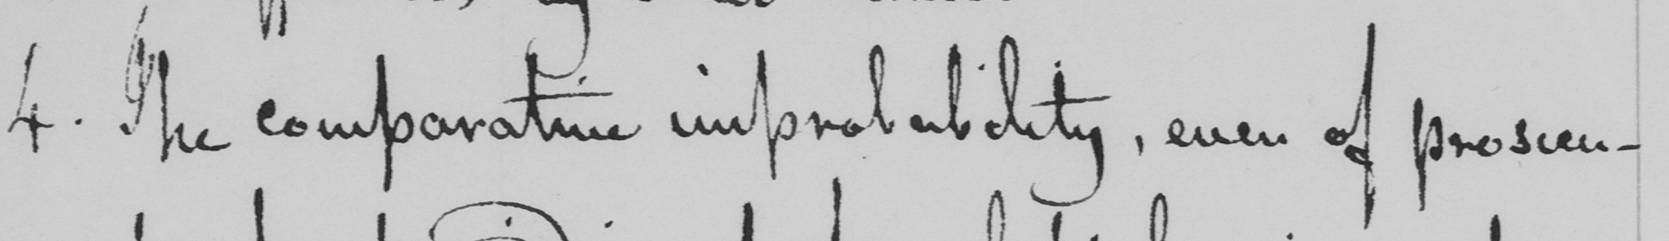What does this handwritten line say? 4 . The comparative improbability , even of prosecu- 